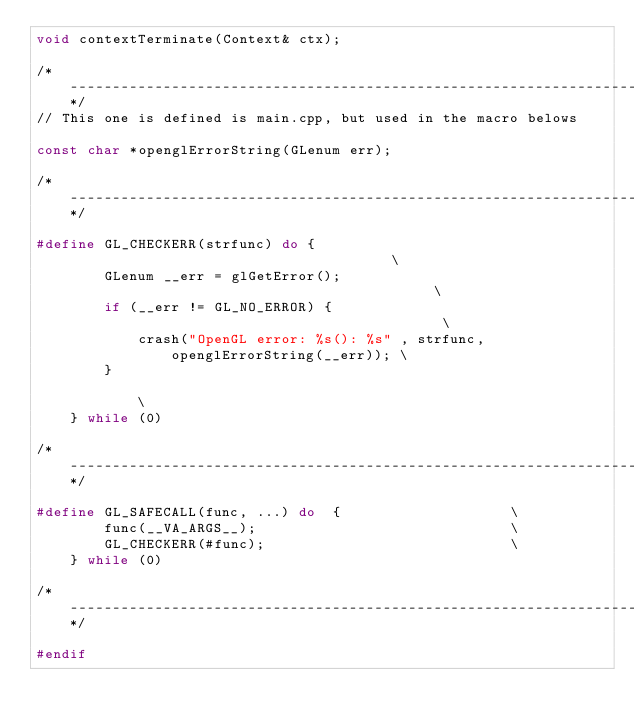<code> <loc_0><loc_0><loc_500><loc_500><_C_>void contextTerminate(Context& ctx);

/*---------------------------------------------------------------------------*/
// This one is defined is main.cpp, but used in the macro belows

const char *openglErrorString(GLenum err);

/*---------------------------------------------------------------------------*/

#define GL_CHECKERR(strfunc) do {                                       \
        GLenum __err = glGetError();                                    \
        if (__err != GL_NO_ERROR) {                                     \
            crash("OpenGL error: %s(): %s" , strfunc, openglErrorString(__err)); \
        }                                                               \
    } while (0)

/*---------------------------------------------------------------------------*/

#define GL_SAFECALL(func, ...) do  {                    \
        func(__VA_ARGS__);                              \
        GL_CHECKERR(#func);                             \
    } while (0)

/*---------------------------------------------------------------------------*/

#endif
</code> 